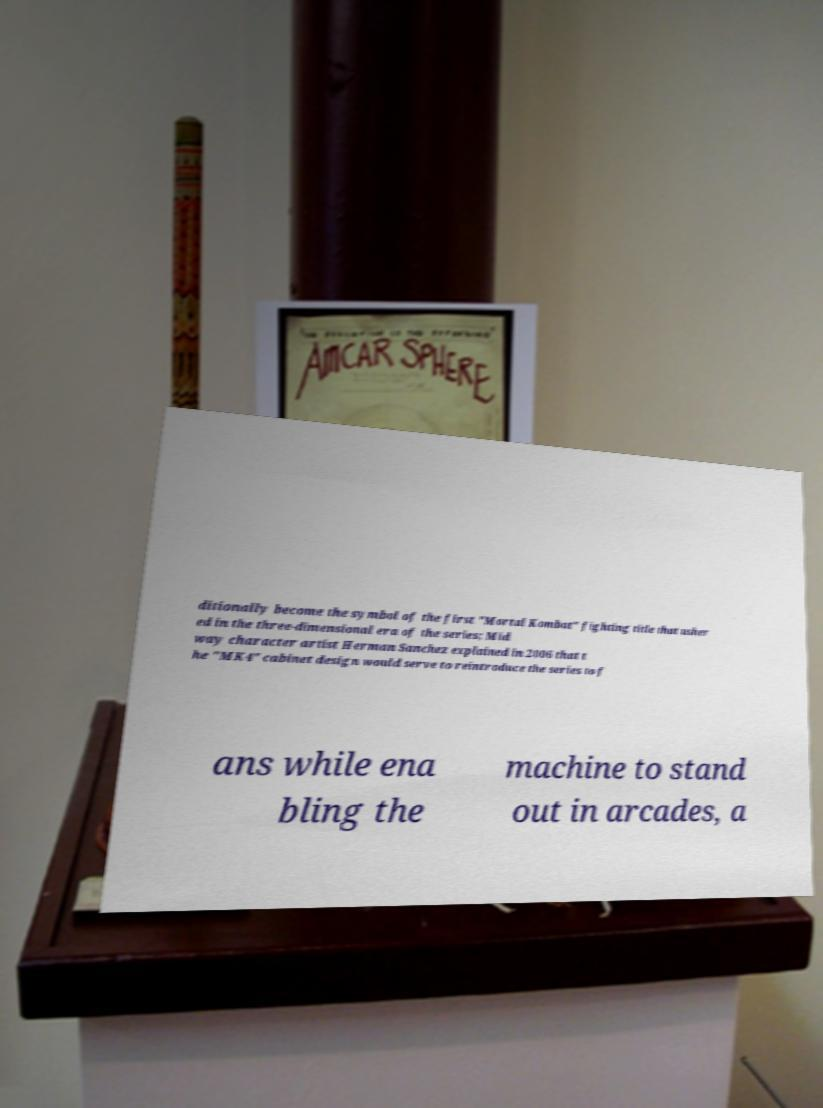Could you assist in decoding the text presented in this image and type it out clearly? ditionally become the symbol of the first "Mortal Kombat" fighting title that usher ed in the three-dimensional era of the series; Mid way character artist Herman Sanchez explained in 2006 that t he "MK4" cabinet design would serve to reintroduce the series to f ans while ena bling the machine to stand out in arcades, a 